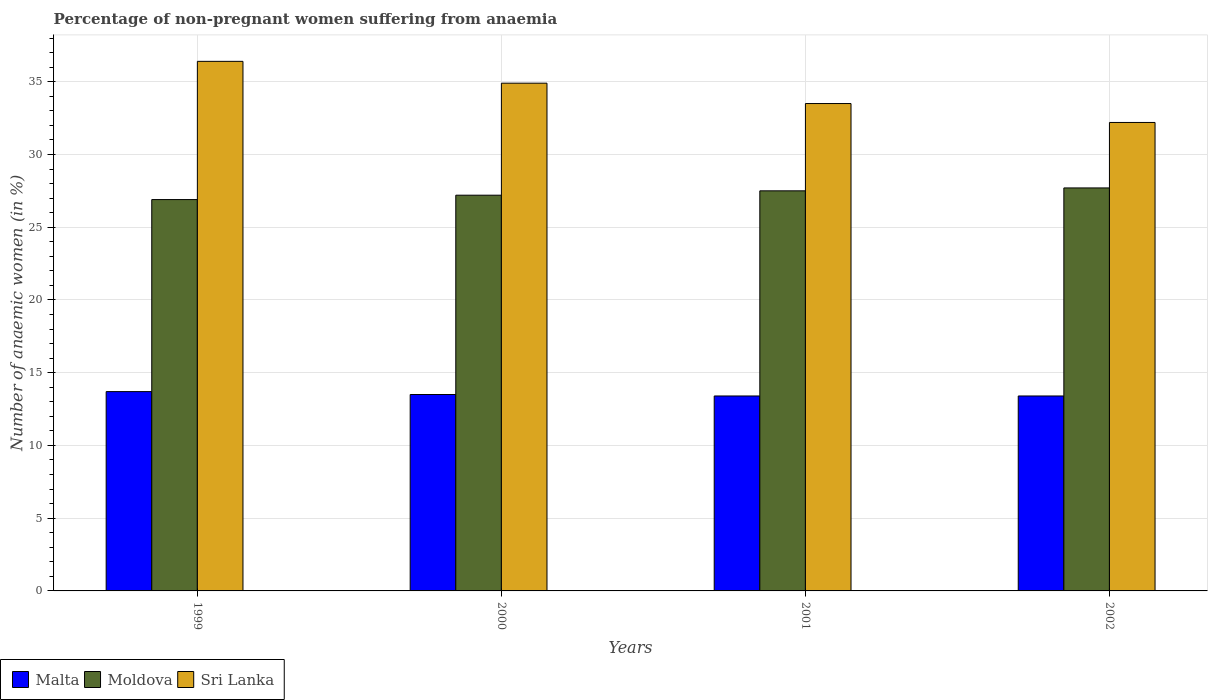How many groups of bars are there?
Make the answer very short. 4. In how many cases, is the number of bars for a given year not equal to the number of legend labels?
Give a very brief answer. 0. What is the percentage of non-pregnant women suffering from anaemia in Sri Lanka in 2001?
Give a very brief answer. 33.5. Across all years, what is the maximum percentage of non-pregnant women suffering from anaemia in Moldova?
Give a very brief answer. 27.7. Across all years, what is the minimum percentage of non-pregnant women suffering from anaemia in Sri Lanka?
Give a very brief answer. 32.2. In which year was the percentage of non-pregnant women suffering from anaemia in Malta minimum?
Make the answer very short. 2001. What is the total percentage of non-pregnant women suffering from anaemia in Moldova in the graph?
Offer a very short reply. 109.3. What is the difference between the percentage of non-pregnant women suffering from anaemia in Sri Lanka in 2001 and the percentage of non-pregnant women suffering from anaemia in Moldova in 1999?
Provide a short and direct response. 6.6. What is the average percentage of non-pregnant women suffering from anaemia in Sri Lanka per year?
Keep it short and to the point. 34.25. In the year 2002, what is the difference between the percentage of non-pregnant women suffering from anaemia in Sri Lanka and percentage of non-pregnant women suffering from anaemia in Moldova?
Provide a succinct answer. 4.5. In how many years, is the percentage of non-pregnant women suffering from anaemia in Moldova greater than 24 %?
Your answer should be very brief. 4. What is the ratio of the percentage of non-pregnant women suffering from anaemia in Sri Lanka in 2000 to that in 2002?
Give a very brief answer. 1.08. What is the difference between the highest and the lowest percentage of non-pregnant women suffering from anaemia in Malta?
Your answer should be compact. 0.3. In how many years, is the percentage of non-pregnant women suffering from anaemia in Malta greater than the average percentage of non-pregnant women suffering from anaemia in Malta taken over all years?
Your response must be concise. 1. What does the 3rd bar from the left in 2002 represents?
Offer a very short reply. Sri Lanka. What does the 2nd bar from the right in 1999 represents?
Your response must be concise. Moldova. Is it the case that in every year, the sum of the percentage of non-pregnant women suffering from anaemia in Malta and percentage of non-pregnant women suffering from anaemia in Moldova is greater than the percentage of non-pregnant women suffering from anaemia in Sri Lanka?
Provide a succinct answer. Yes. Are all the bars in the graph horizontal?
Make the answer very short. No. How many years are there in the graph?
Give a very brief answer. 4. What is the difference between two consecutive major ticks on the Y-axis?
Offer a very short reply. 5. Are the values on the major ticks of Y-axis written in scientific E-notation?
Your answer should be compact. No. Does the graph contain grids?
Provide a short and direct response. Yes. What is the title of the graph?
Provide a succinct answer. Percentage of non-pregnant women suffering from anaemia. What is the label or title of the Y-axis?
Offer a terse response. Number of anaemic women (in %). What is the Number of anaemic women (in %) in Moldova in 1999?
Keep it short and to the point. 26.9. What is the Number of anaemic women (in %) in Sri Lanka in 1999?
Make the answer very short. 36.4. What is the Number of anaemic women (in %) of Malta in 2000?
Your answer should be very brief. 13.5. What is the Number of anaemic women (in %) in Moldova in 2000?
Your answer should be compact. 27.2. What is the Number of anaemic women (in %) in Sri Lanka in 2000?
Give a very brief answer. 34.9. What is the Number of anaemic women (in %) in Malta in 2001?
Provide a succinct answer. 13.4. What is the Number of anaemic women (in %) of Sri Lanka in 2001?
Your answer should be compact. 33.5. What is the Number of anaemic women (in %) of Malta in 2002?
Your answer should be compact. 13.4. What is the Number of anaemic women (in %) of Moldova in 2002?
Provide a short and direct response. 27.7. What is the Number of anaemic women (in %) of Sri Lanka in 2002?
Your response must be concise. 32.2. Across all years, what is the maximum Number of anaemic women (in %) of Moldova?
Offer a very short reply. 27.7. Across all years, what is the maximum Number of anaemic women (in %) in Sri Lanka?
Keep it short and to the point. 36.4. Across all years, what is the minimum Number of anaemic women (in %) of Malta?
Your response must be concise. 13.4. Across all years, what is the minimum Number of anaemic women (in %) in Moldova?
Offer a very short reply. 26.9. Across all years, what is the minimum Number of anaemic women (in %) in Sri Lanka?
Your answer should be compact. 32.2. What is the total Number of anaemic women (in %) of Malta in the graph?
Provide a succinct answer. 54. What is the total Number of anaemic women (in %) in Moldova in the graph?
Keep it short and to the point. 109.3. What is the total Number of anaemic women (in %) in Sri Lanka in the graph?
Your response must be concise. 137. What is the difference between the Number of anaemic women (in %) of Malta in 1999 and that in 2000?
Make the answer very short. 0.2. What is the difference between the Number of anaemic women (in %) in Malta in 1999 and that in 2001?
Provide a short and direct response. 0.3. What is the difference between the Number of anaemic women (in %) of Moldova in 1999 and that in 2001?
Your answer should be very brief. -0.6. What is the difference between the Number of anaemic women (in %) of Malta in 1999 and that in 2002?
Make the answer very short. 0.3. What is the difference between the Number of anaemic women (in %) of Malta in 2000 and that in 2001?
Ensure brevity in your answer.  0.1. What is the difference between the Number of anaemic women (in %) in Sri Lanka in 2000 and that in 2001?
Provide a short and direct response. 1.4. What is the difference between the Number of anaemic women (in %) of Malta in 2000 and that in 2002?
Offer a terse response. 0.1. What is the difference between the Number of anaemic women (in %) of Sri Lanka in 2000 and that in 2002?
Provide a succinct answer. 2.7. What is the difference between the Number of anaemic women (in %) of Moldova in 2001 and that in 2002?
Your response must be concise. -0.2. What is the difference between the Number of anaemic women (in %) of Sri Lanka in 2001 and that in 2002?
Offer a very short reply. 1.3. What is the difference between the Number of anaemic women (in %) of Malta in 1999 and the Number of anaemic women (in %) of Moldova in 2000?
Your answer should be compact. -13.5. What is the difference between the Number of anaemic women (in %) in Malta in 1999 and the Number of anaemic women (in %) in Sri Lanka in 2000?
Your answer should be very brief. -21.2. What is the difference between the Number of anaemic women (in %) in Malta in 1999 and the Number of anaemic women (in %) in Moldova in 2001?
Your answer should be very brief. -13.8. What is the difference between the Number of anaemic women (in %) in Malta in 1999 and the Number of anaemic women (in %) in Sri Lanka in 2001?
Your response must be concise. -19.8. What is the difference between the Number of anaemic women (in %) of Moldova in 1999 and the Number of anaemic women (in %) of Sri Lanka in 2001?
Offer a terse response. -6.6. What is the difference between the Number of anaemic women (in %) in Malta in 1999 and the Number of anaemic women (in %) in Sri Lanka in 2002?
Your response must be concise. -18.5. What is the difference between the Number of anaemic women (in %) in Moldova in 1999 and the Number of anaemic women (in %) in Sri Lanka in 2002?
Provide a short and direct response. -5.3. What is the difference between the Number of anaemic women (in %) in Malta in 2000 and the Number of anaemic women (in %) in Moldova in 2001?
Provide a succinct answer. -14. What is the difference between the Number of anaemic women (in %) in Moldova in 2000 and the Number of anaemic women (in %) in Sri Lanka in 2001?
Offer a terse response. -6.3. What is the difference between the Number of anaemic women (in %) of Malta in 2000 and the Number of anaemic women (in %) of Sri Lanka in 2002?
Provide a short and direct response. -18.7. What is the difference between the Number of anaemic women (in %) of Malta in 2001 and the Number of anaemic women (in %) of Moldova in 2002?
Keep it short and to the point. -14.3. What is the difference between the Number of anaemic women (in %) in Malta in 2001 and the Number of anaemic women (in %) in Sri Lanka in 2002?
Offer a very short reply. -18.8. What is the difference between the Number of anaemic women (in %) of Moldova in 2001 and the Number of anaemic women (in %) of Sri Lanka in 2002?
Keep it short and to the point. -4.7. What is the average Number of anaemic women (in %) in Malta per year?
Give a very brief answer. 13.5. What is the average Number of anaemic women (in %) of Moldova per year?
Provide a succinct answer. 27.32. What is the average Number of anaemic women (in %) of Sri Lanka per year?
Give a very brief answer. 34.25. In the year 1999, what is the difference between the Number of anaemic women (in %) of Malta and Number of anaemic women (in %) of Moldova?
Make the answer very short. -13.2. In the year 1999, what is the difference between the Number of anaemic women (in %) of Malta and Number of anaemic women (in %) of Sri Lanka?
Ensure brevity in your answer.  -22.7. In the year 2000, what is the difference between the Number of anaemic women (in %) of Malta and Number of anaemic women (in %) of Moldova?
Your answer should be very brief. -13.7. In the year 2000, what is the difference between the Number of anaemic women (in %) in Malta and Number of anaemic women (in %) in Sri Lanka?
Offer a terse response. -21.4. In the year 2000, what is the difference between the Number of anaemic women (in %) of Moldova and Number of anaemic women (in %) of Sri Lanka?
Offer a terse response. -7.7. In the year 2001, what is the difference between the Number of anaemic women (in %) of Malta and Number of anaemic women (in %) of Moldova?
Provide a short and direct response. -14.1. In the year 2001, what is the difference between the Number of anaemic women (in %) in Malta and Number of anaemic women (in %) in Sri Lanka?
Ensure brevity in your answer.  -20.1. In the year 2002, what is the difference between the Number of anaemic women (in %) in Malta and Number of anaemic women (in %) in Moldova?
Keep it short and to the point. -14.3. In the year 2002, what is the difference between the Number of anaemic women (in %) in Malta and Number of anaemic women (in %) in Sri Lanka?
Offer a terse response. -18.8. What is the ratio of the Number of anaemic women (in %) of Malta in 1999 to that in 2000?
Provide a short and direct response. 1.01. What is the ratio of the Number of anaemic women (in %) in Moldova in 1999 to that in 2000?
Offer a terse response. 0.99. What is the ratio of the Number of anaemic women (in %) in Sri Lanka in 1999 to that in 2000?
Make the answer very short. 1.04. What is the ratio of the Number of anaemic women (in %) of Malta in 1999 to that in 2001?
Give a very brief answer. 1.02. What is the ratio of the Number of anaemic women (in %) in Moldova in 1999 to that in 2001?
Give a very brief answer. 0.98. What is the ratio of the Number of anaemic women (in %) of Sri Lanka in 1999 to that in 2001?
Ensure brevity in your answer.  1.09. What is the ratio of the Number of anaemic women (in %) in Malta in 1999 to that in 2002?
Offer a terse response. 1.02. What is the ratio of the Number of anaemic women (in %) of Moldova in 1999 to that in 2002?
Your answer should be very brief. 0.97. What is the ratio of the Number of anaemic women (in %) in Sri Lanka in 1999 to that in 2002?
Give a very brief answer. 1.13. What is the ratio of the Number of anaemic women (in %) in Malta in 2000 to that in 2001?
Your response must be concise. 1.01. What is the ratio of the Number of anaemic women (in %) of Moldova in 2000 to that in 2001?
Your answer should be very brief. 0.99. What is the ratio of the Number of anaemic women (in %) of Sri Lanka in 2000 to that in 2001?
Offer a very short reply. 1.04. What is the ratio of the Number of anaemic women (in %) in Malta in 2000 to that in 2002?
Keep it short and to the point. 1.01. What is the ratio of the Number of anaemic women (in %) of Moldova in 2000 to that in 2002?
Ensure brevity in your answer.  0.98. What is the ratio of the Number of anaemic women (in %) in Sri Lanka in 2000 to that in 2002?
Ensure brevity in your answer.  1.08. What is the ratio of the Number of anaemic women (in %) of Sri Lanka in 2001 to that in 2002?
Provide a succinct answer. 1.04. What is the difference between the highest and the second highest Number of anaemic women (in %) in Malta?
Give a very brief answer. 0.2. What is the difference between the highest and the second highest Number of anaemic women (in %) of Moldova?
Give a very brief answer. 0.2. What is the difference between the highest and the lowest Number of anaemic women (in %) in Moldova?
Make the answer very short. 0.8. 